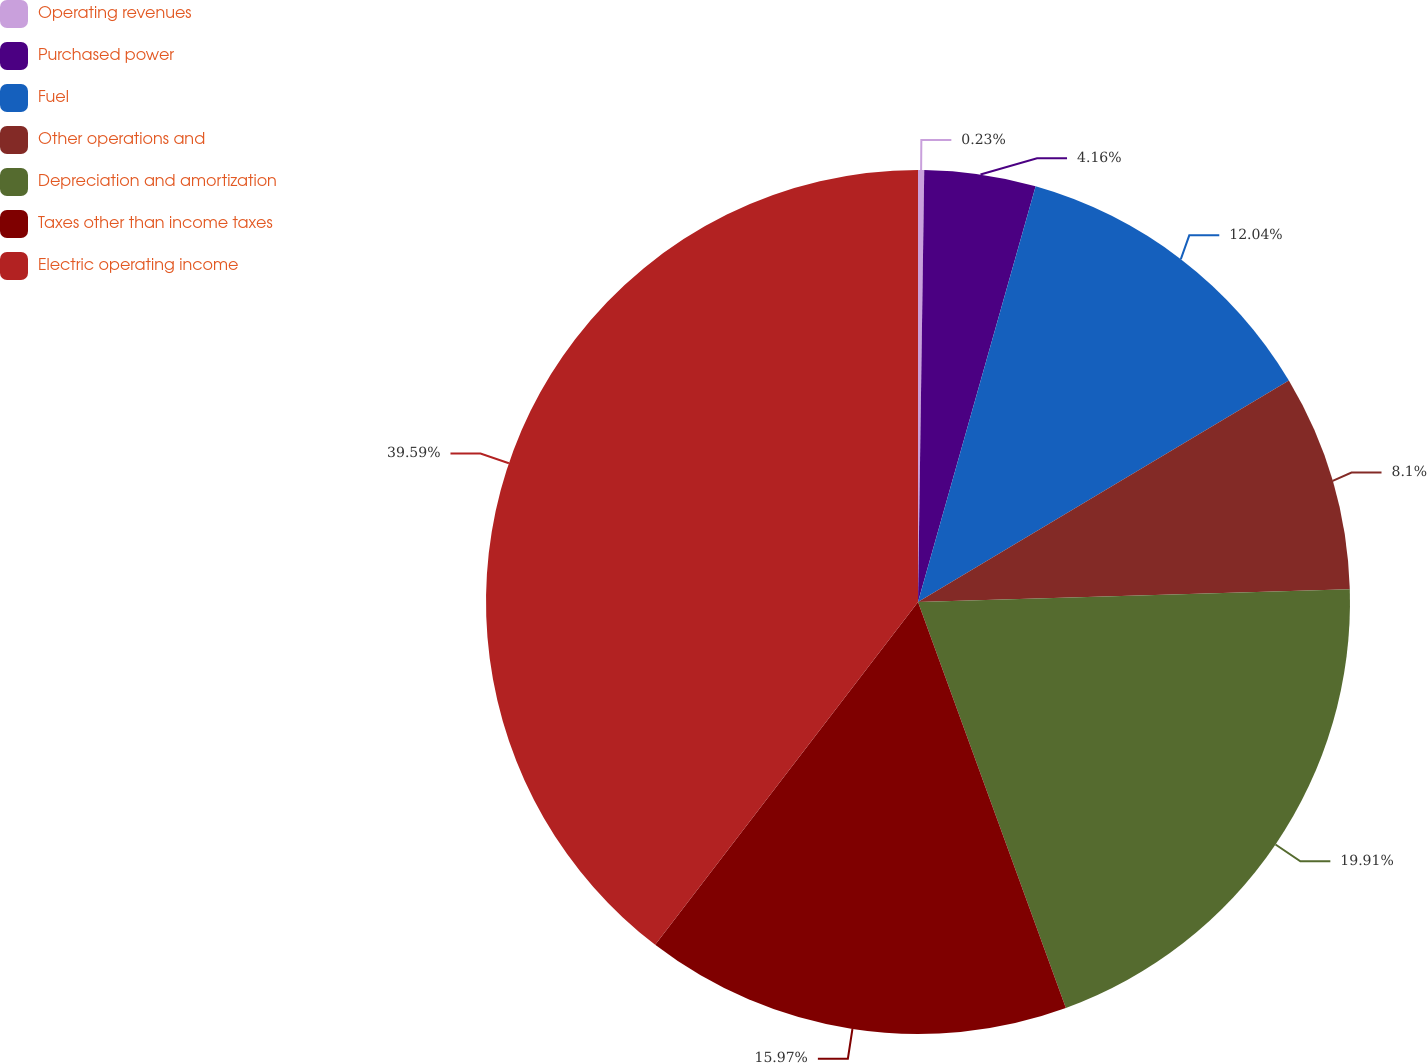Convert chart to OTSL. <chart><loc_0><loc_0><loc_500><loc_500><pie_chart><fcel>Operating revenues<fcel>Purchased power<fcel>Fuel<fcel>Other operations and<fcel>Depreciation and amortization<fcel>Taxes other than income taxes<fcel>Electric operating income<nl><fcel>0.23%<fcel>4.16%<fcel>12.04%<fcel>8.1%<fcel>19.91%<fcel>15.97%<fcel>39.59%<nl></chart> 